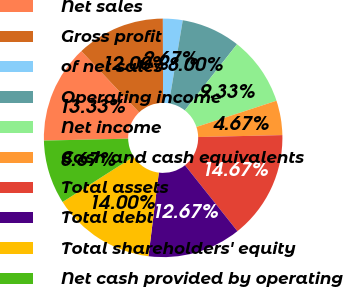Convert chart. <chart><loc_0><loc_0><loc_500><loc_500><pie_chart><fcel>Net sales<fcel>Gross profit<fcel>of net sales<fcel>Operating income<fcel>Net income<fcel>Cash and cash equivalents<fcel>Total assets<fcel>Total debt<fcel>Total shareholders' equity<fcel>Net cash provided by operating<nl><fcel>13.33%<fcel>12.0%<fcel>2.67%<fcel>8.0%<fcel>9.33%<fcel>4.67%<fcel>14.67%<fcel>12.67%<fcel>14.0%<fcel>8.67%<nl></chart> 